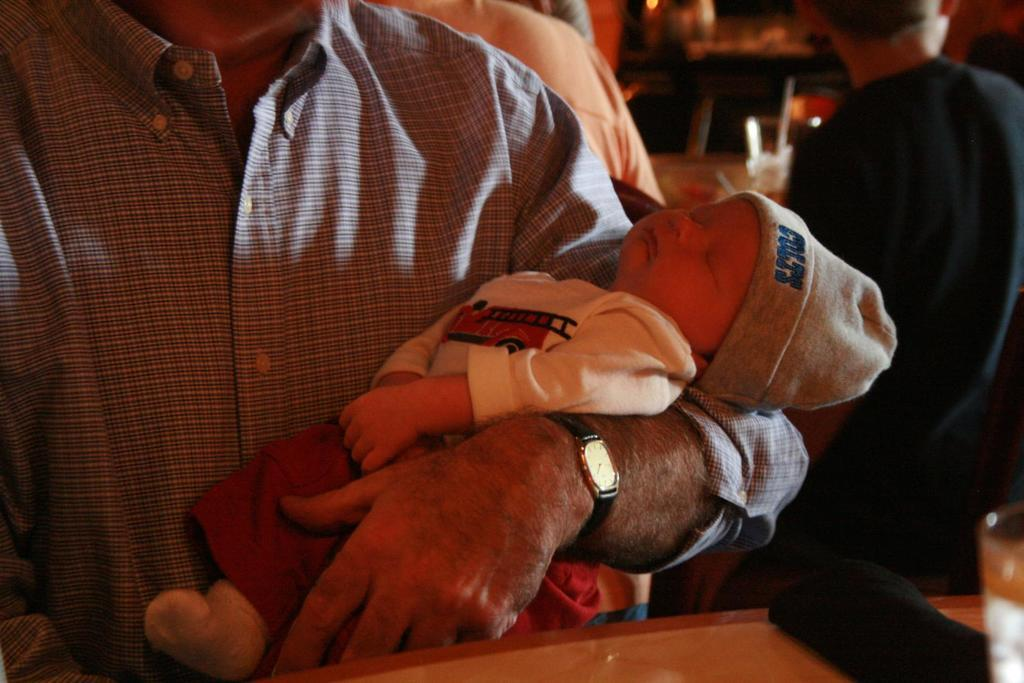<image>
Summarize the visual content of the image. A man is holding an infant that has a COLTS hat on. 